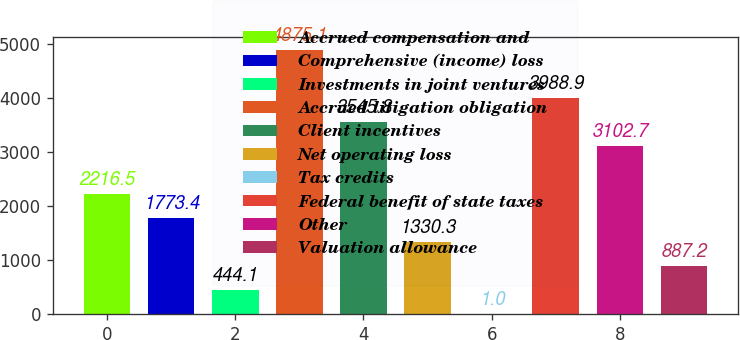Convert chart. <chart><loc_0><loc_0><loc_500><loc_500><bar_chart><fcel>Accrued compensation and<fcel>Comprehensive (income) loss<fcel>Investments in joint ventures<fcel>Accrued litigation obligation<fcel>Client incentives<fcel>Net operating loss<fcel>Tax credits<fcel>Federal benefit of state taxes<fcel>Other<fcel>Valuation allowance<nl><fcel>2216.5<fcel>1773.4<fcel>444.1<fcel>4875.1<fcel>3545.8<fcel>1330.3<fcel>1<fcel>3988.9<fcel>3102.7<fcel>887.2<nl></chart> 